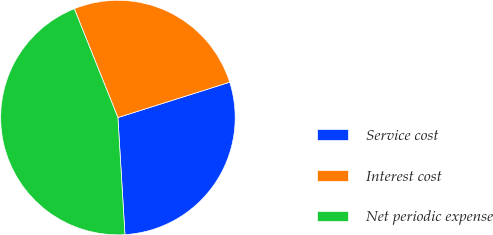Convert chart to OTSL. <chart><loc_0><loc_0><loc_500><loc_500><pie_chart><fcel>Service cost<fcel>Interest cost<fcel>Net periodic expense<nl><fcel>28.92%<fcel>26.19%<fcel>44.89%<nl></chart> 